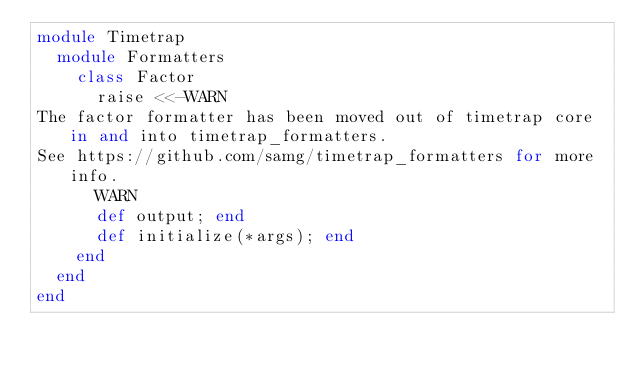<code> <loc_0><loc_0><loc_500><loc_500><_Ruby_>module Timetrap
  module Formatters
    class Factor
      raise <<-WARN
The factor formatter has been moved out of timetrap core in and into timetrap_formatters.
See https://github.com/samg/timetrap_formatters for more info.
      WARN
      def output; end
      def initialize(*args); end
    end
  end
end
</code> 